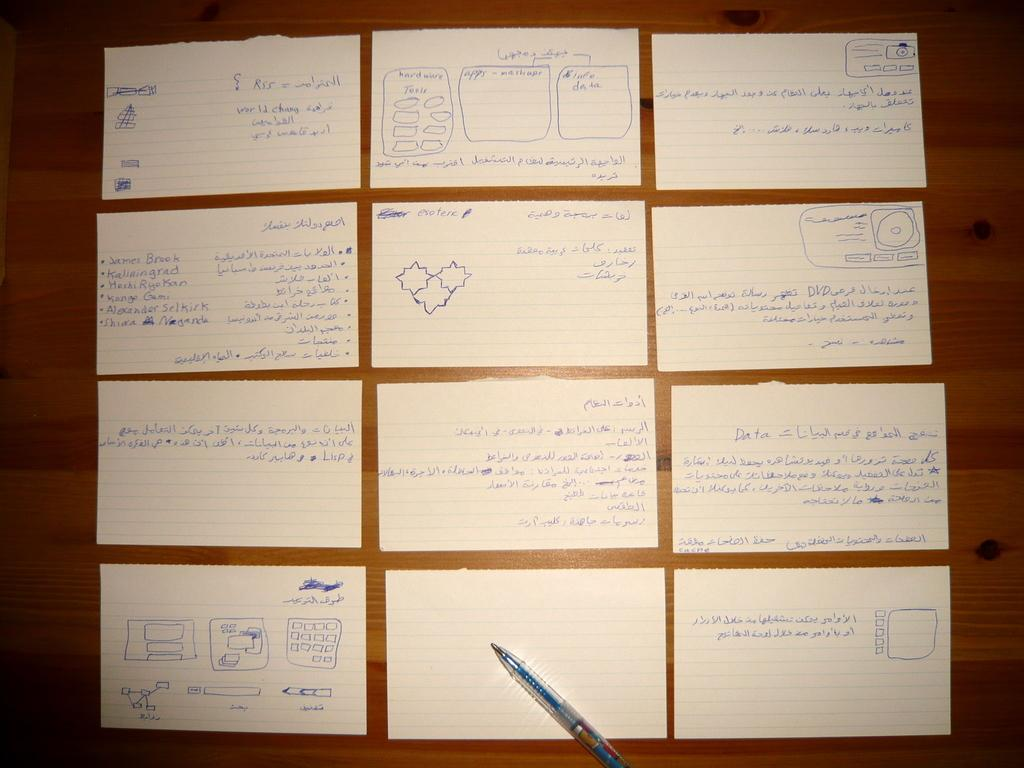What is on the papers that are visible in the image? The papers in the image have text and drawings on them. What tool is used for writing or drawing on the papers? A pen is visible in the image. Where are the papers and pen located? The papers and pen are on a table. What type of steel is used to construct the sofa in the image? There is no sofa present in the image; it only features papers, a pen, and a table. How much land is visible in the image? The image does not depict any land; it only shows papers, a pen, and a table. 